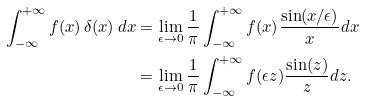<formula> <loc_0><loc_0><loc_500><loc_500>\int _ { - \infty } ^ { + \infty } f ( x ) \, \delta ( x ) \, d x & = \lim _ { \epsilon \rightarrow 0 } \frac { 1 } { \pi } \int _ { - \infty } ^ { + \infty } f ( x ) \frac { \sin ( x / \epsilon ) } { x } d x \\ & = \lim _ { \epsilon \rightarrow 0 } \frac { 1 } { \pi } \int _ { - \infty } ^ { + \infty } f ( \epsilon z ) \frac { \sin ( z ) } { z } d z .</formula> 